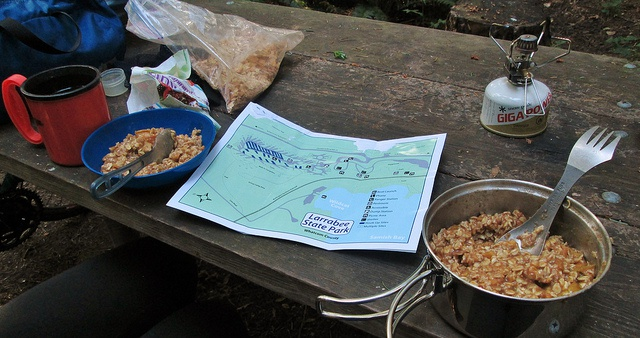Describe the objects in this image and their specific colors. I can see dining table in black and gray tones, people in black tones, backpack in darkgray, black, navy, blue, and darkblue tones, handbag in black, navy, blue, and darkblue tones, and bowl in black, navy, gray, and tan tones in this image. 